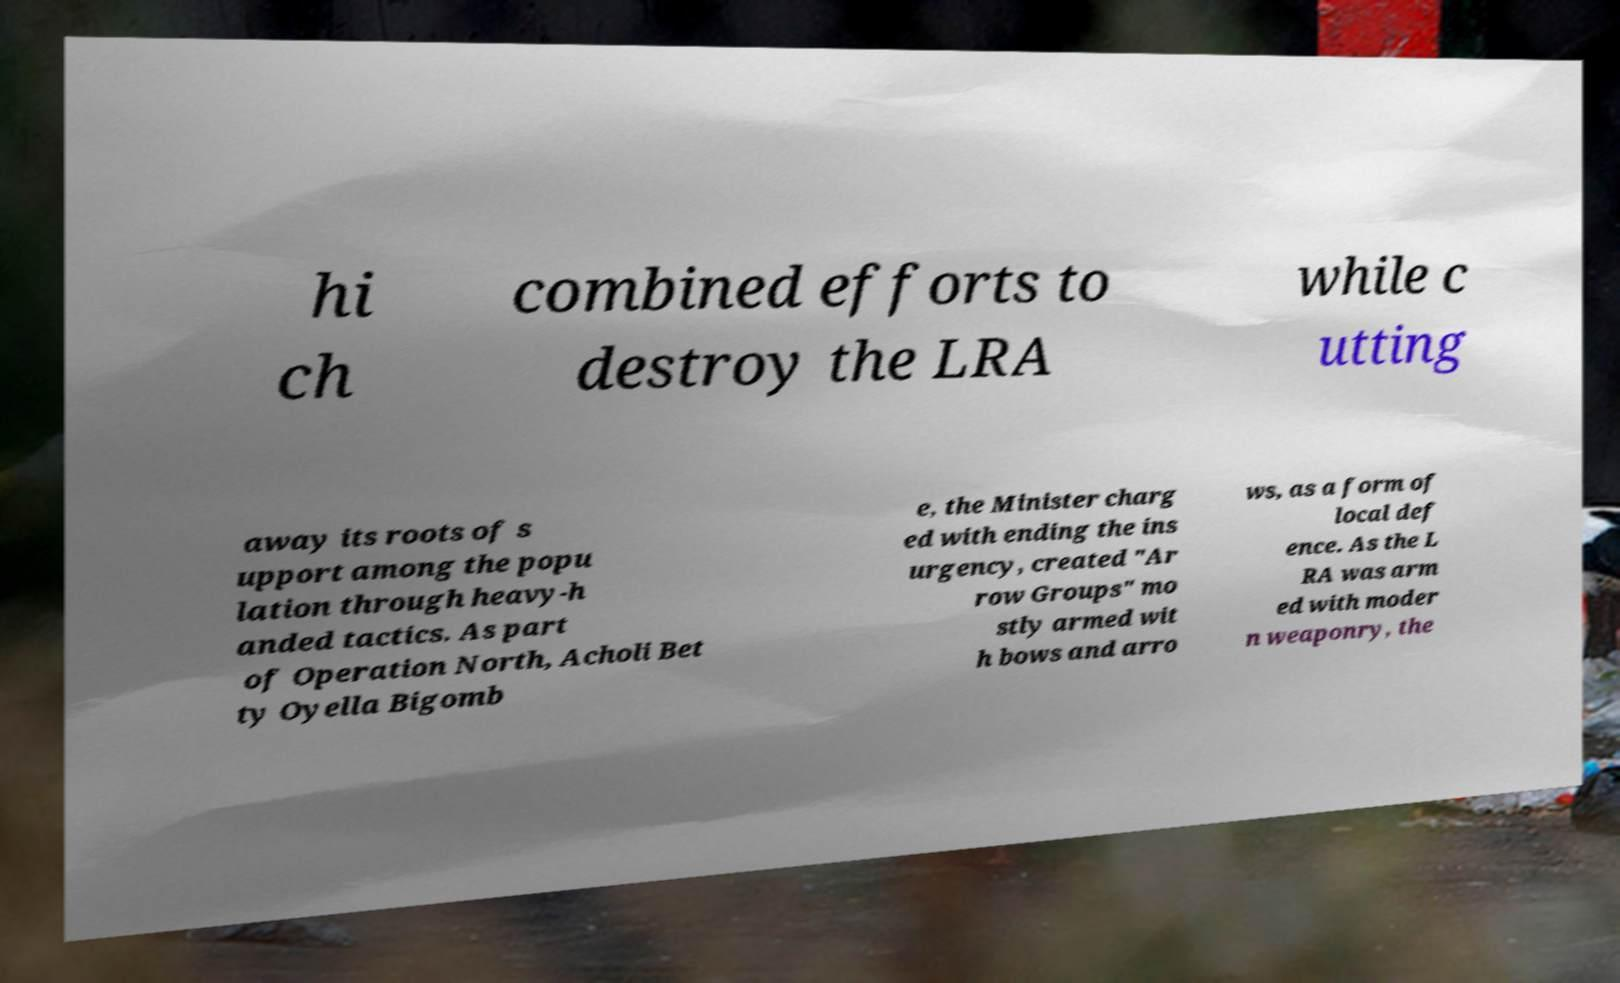Can you read and provide the text displayed in the image?This photo seems to have some interesting text. Can you extract and type it out for me? hi ch combined efforts to destroy the LRA while c utting away its roots of s upport among the popu lation through heavy-h anded tactics. As part of Operation North, Acholi Bet ty Oyella Bigomb e, the Minister charg ed with ending the ins urgency, created "Ar row Groups" mo stly armed wit h bows and arro ws, as a form of local def ence. As the L RA was arm ed with moder n weaponry, the 